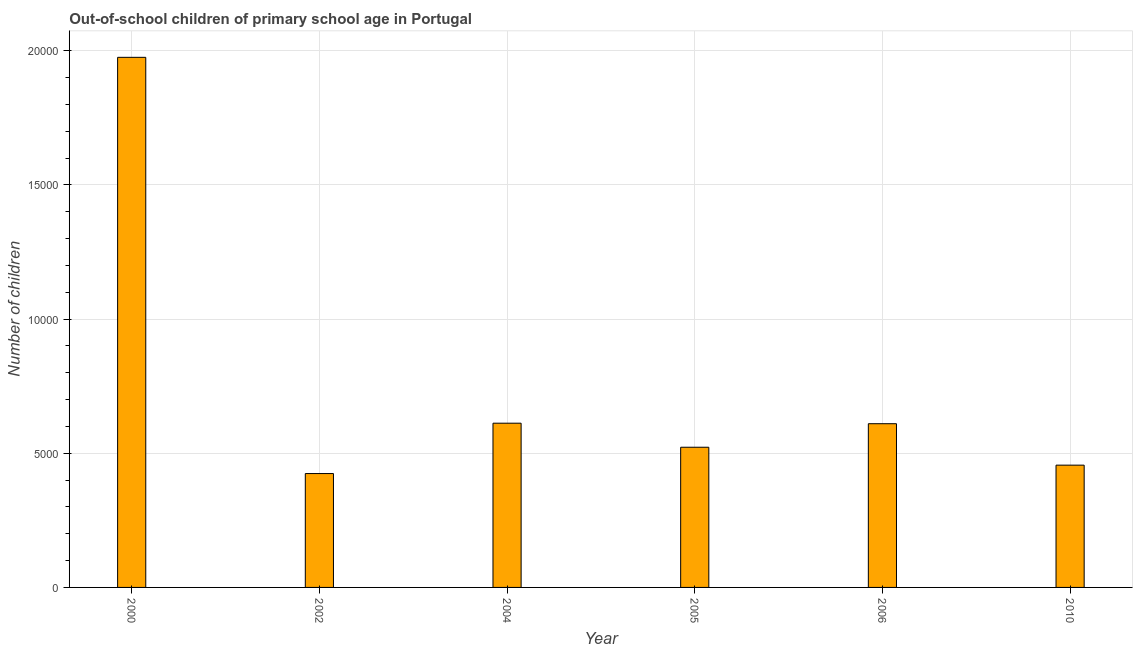Does the graph contain any zero values?
Provide a short and direct response. No. Does the graph contain grids?
Ensure brevity in your answer.  Yes. What is the title of the graph?
Provide a short and direct response. Out-of-school children of primary school age in Portugal. What is the label or title of the Y-axis?
Keep it short and to the point. Number of children. What is the number of out-of-school children in 2004?
Provide a succinct answer. 6119. Across all years, what is the maximum number of out-of-school children?
Give a very brief answer. 1.98e+04. Across all years, what is the minimum number of out-of-school children?
Offer a terse response. 4243. What is the sum of the number of out-of-school children?
Provide a short and direct response. 4.60e+04. What is the difference between the number of out-of-school children in 2006 and 2010?
Your answer should be very brief. 1544. What is the average number of out-of-school children per year?
Provide a succinct answer. 7665. What is the median number of out-of-school children?
Your answer should be compact. 5661.5. What is the ratio of the number of out-of-school children in 2000 to that in 2010?
Offer a very short reply. 4.33. Is the number of out-of-school children in 2004 less than that in 2006?
Offer a very short reply. No. Is the difference between the number of out-of-school children in 2002 and 2004 greater than the difference between any two years?
Your answer should be compact. No. What is the difference between the highest and the second highest number of out-of-school children?
Your answer should be compact. 1.36e+04. What is the difference between the highest and the lowest number of out-of-school children?
Provide a succinct answer. 1.55e+04. Are all the bars in the graph horizontal?
Offer a very short reply. No. Are the values on the major ticks of Y-axis written in scientific E-notation?
Offer a very short reply. No. What is the Number of children of 2000?
Give a very brief answer. 1.98e+04. What is the Number of children in 2002?
Make the answer very short. 4243. What is the Number of children in 2004?
Offer a very short reply. 6119. What is the Number of children in 2005?
Your answer should be compact. 5223. What is the Number of children of 2006?
Keep it short and to the point. 6100. What is the Number of children in 2010?
Provide a short and direct response. 4556. What is the difference between the Number of children in 2000 and 2002?
Give a very brief answer. 1.55e+04. What is the difference between the Number of children in 2000 and 2004?
Give a very brief answer. 1.36e+04. What is the difference between the Number of children in 2000 and 2005?
Your response must be concise. 1.45e+04. What is the difference between the Number of children in 2000 and 2006?
Your answer should be very brief. 1.37e+04. What is the difference between the Number of children in 2000 and 2010?
Your answer should be very brief. 1.52e+04. What is the difference between the Number of children in 2002 and 2004?
Provide a short and direct response. -1876. What is the difference between the Number of children in 2002 and 2005?
Make the answer very short. -980. What is the difference between the Number of children in 2002 and 2006?
Ensure brevity in your answer.  -1857. What is the difference between the Number of children in 2002 and 2010?
Your response must be concise. -313. What is the difference between the Number of children in 2004 and 2005?
Give a very brief answer. 896. What is the difference between the Number of children in 2004 and 2006?
Your answer should be very brief. 19. What is the difference between the Number of children in 2004 and 2010?
Make the answer very short. 1563. What is the difference between the Number of children in 2005 and 2006?
Provide a succinct answer. -877. What is the difference between the Number of children in 2005 and 2010?
Offer a terse response. 667. What is the difference between the Number of children in 2006 and 2010?
Offer a terse response. 1544. What is the ratio of the Number of children in 2000 to that in 2002?
Your response must be concise. 4.66. What is the ratio of the Number of children in 2000 to that in 2004?
Keep it short and to the point. 3.23. What is the ratio of the Number of children in 2000 to that in 2005?
Give a very brief answer. 3.78. What is the ratio of the Number of children in 2000 to that in 2006?
Give a very brief answer. 3.24. What is the ratio of the Number of children in 2000 to that in 2010?
Your response must be concise. 4.33. What is the ratio of the Number of children in 2002 to that in 2004?
Ensure brevity in your answer.  0.69. What is the ratio of the Number of children in 2002 to that in 2005?
Provide a short and direct response. 0.81. What is the ratio of the Number of children in 2002 to that in 2006?
Make the answer very short. 0.7. What is the ratio of the Number of children in 2004 to that in 2005?
Your answer should be very brief. 1.17. What is the ratio of the Number of children in 2004 to that in 2006?
Offer a terse response. 1. What is the ratio of the Number of children in 2004 to that in 2010?
Your response must be concise. 1.34. What is the ratio of the Number of children in 2005 to that in 2006?
Your answer should be very brief. 0.86. What is the ratio of the Number of children in 2005 to that in 2010?
Make the answer very short. 1.15. What is the ratio of the Number of children in 2006 to that in 2010?
Offer a terse response. 1.34. 